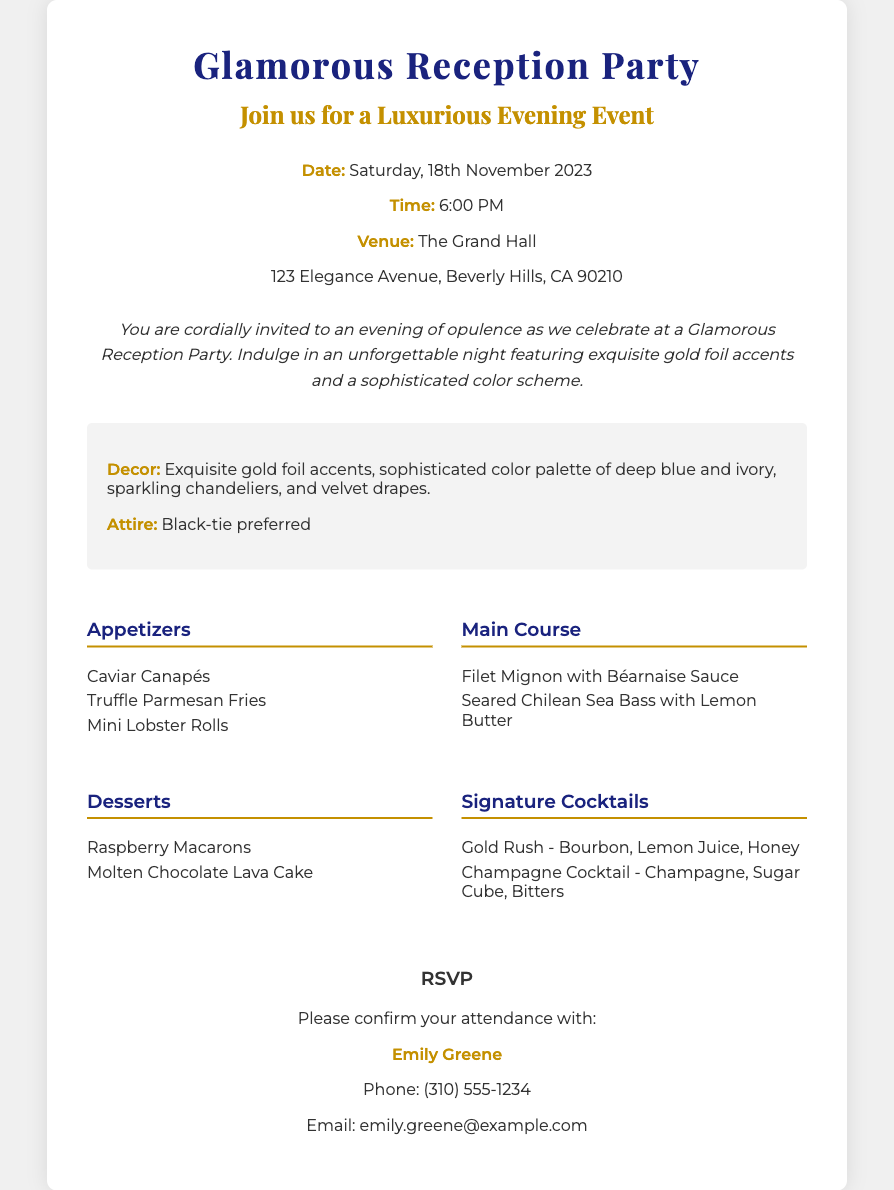What is the date of the event? The date is mentioned in the details section of the invitation as Saturday, 18th November 2023.
Answer: Saturday, 18th November 2023 What time does the reception party start? The time is stated in the details section, specified as 6:00 PM.
Answer: 6:00 PM Where is the venue located? The venue details are provided in the invitation, stating The Grand Hall and its address.
Answer: The Grand Hall, 123 Elegance Avenue, Beverly Hills, CA 90210 What is the preferred attire for the event? The attire is mentioned in the highlights section of the invitation as black-tie preferred.
Answer: Black-tie preferred Which dessert is listed on the menu? The dessert section of the menu preview includes Raspberry Macarons.
Answer: Raspberry Macarons How many appetizers are listed in the menu? There are three appetizers listed under the appetizers section in the menu preview.
Answer: Three What type of cocktails are featured? The signature cocktails section lists specific cocktails to be served at the event, including a Gold Rush and a Champagne Cocktail.
Answer: Gold Rush, Champagne Cocktail Who should attendees confirm their attendance with? The RSVP section specifies that attendees should confirm with Emily Greene.
Answer: Emily Greene What color accents are highlighted in the decor? The highlights section mentions exquisite gold foil accents and a sophisticated color palette of deep blue and ivory for decor.
Answer: Gold foil accents, deep blue and ivory 